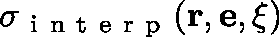Convert formula to latex. <formula><loc_0><loc_0><loc_500><loc_500>\sigma _ { i n t e r p } ( r , e , \xi )</formula> 